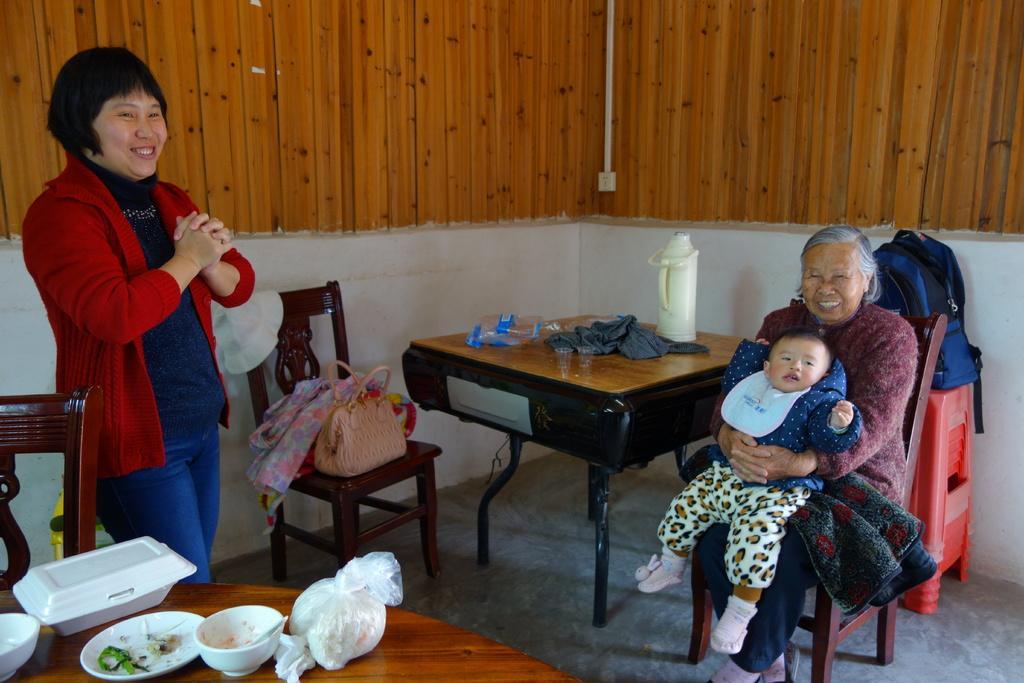Please provide a concise description of this image. This is the picture in a room where we have two tables and chairs and three people and a lady holding a small boy and sitting on a chair and behind them there are some red stools on which their is a backpack and on the table there is a cloth and a chair and on chair there is a stole and a hand bag. 